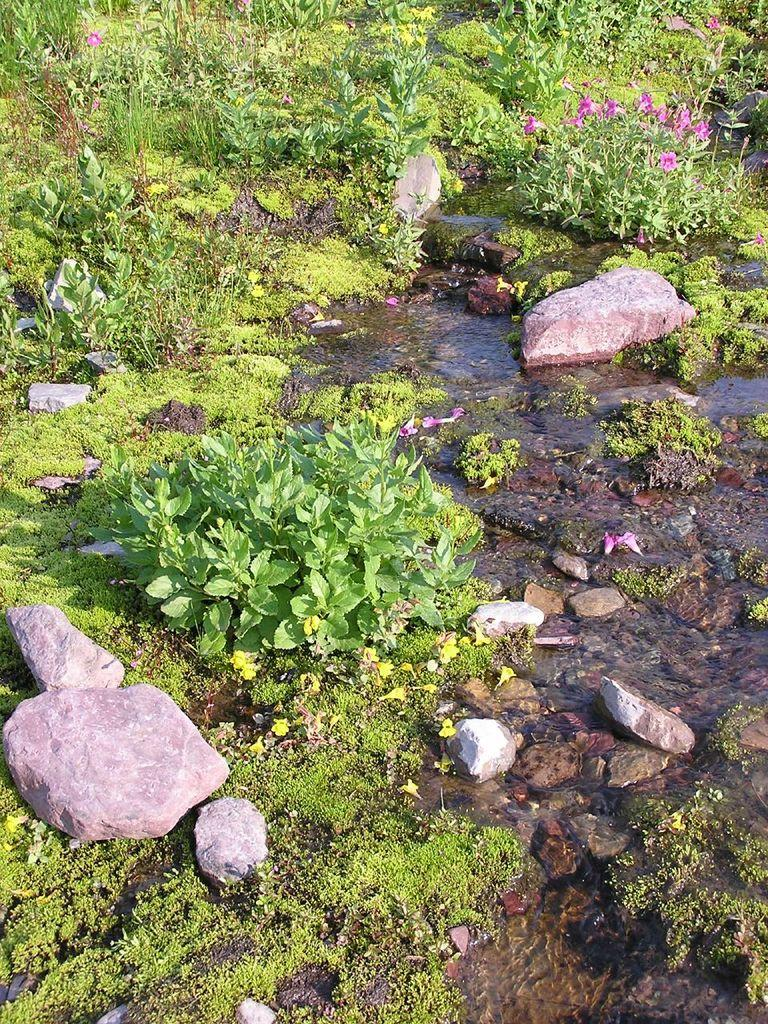What type of natural elements can be seen in the image? There are rocks, water, small plants, flowers, and grass visible in the image. Can you describe the water in the image? The water is visible in the image, but its specific characteristics are not mentioned in the facts. What type of vegetation is present in the image? There are small plants and flowers in the image. What is the ground covered with in the image? The ground is covered with grass in the image. What type of canvas is being used to paint the rocks in the image? There is no canvas or painting activity present in the image; it features natural elements such as rocks, water, small plants, flowers, and grass. 